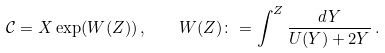<formula> <loc_0><loc_0><loc_500><loc_500>\mathcal { C } = X \exp ( W ( Z ) ) \, , \quad W ( Z ) \colon = \int ^ { Z } \frac { d Y } { U ( Y ) + 2 Y } \, .</formula> 